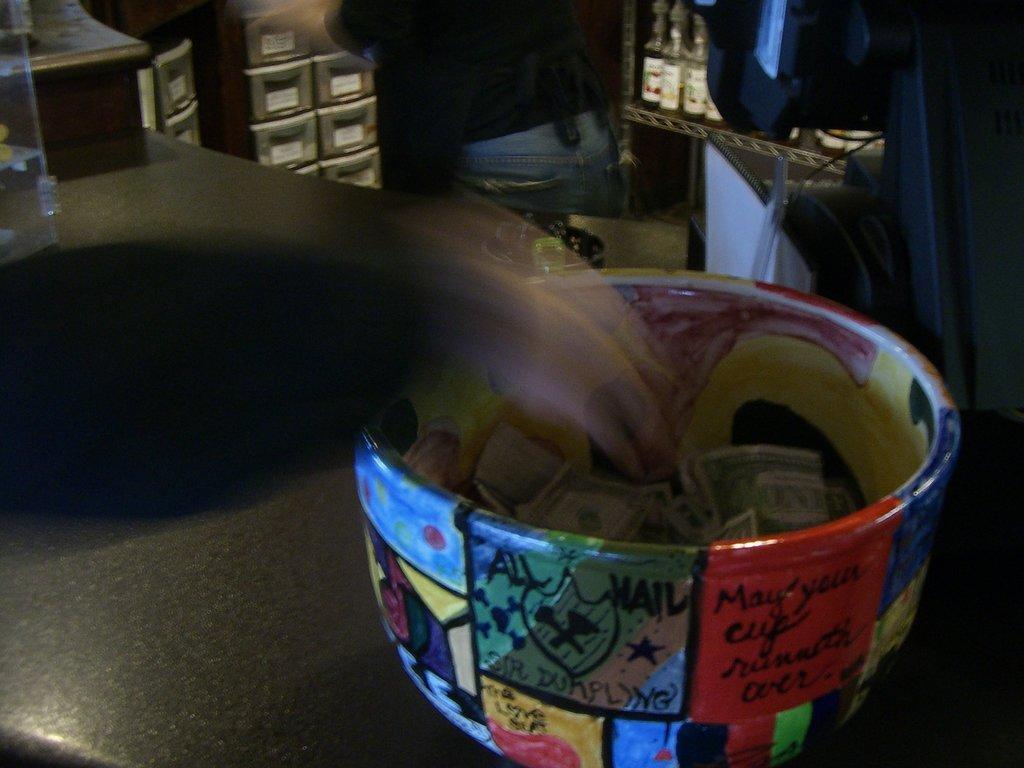Please provide a concise description of this image. In this image we can see a box on a table. In the box we can see the money. Behind the table, we can see a truncated person and racks. On the right side, we can see a black object. Beside the person we can see few bottles on a table. In the top left, we can see a glass object on a table. 